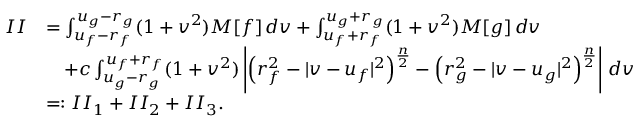<formula> <loc_0><loc_0><loc_500><loc_500>\begin{array} { r l } { I I } & { = \int _ { u _ { f } - r _ { f } } ^ { u _ { g } - r _ { g } } ( 1 + v ^ { 2 } ) M [ f ] \, d v + \int _ { u _ { f } + r _ { f } } ^ { u _ { g } + r _ { g } } ( 1 + v ^ { 2 } ) M [ g ] \, d v } \\ & { \quad + c \int _ { u _ { g } - r _ { g } } ^ { u _ { f } + r _ { f } } ( 1 + v ^ { 2 } ) \left | \left ( r _ { f } ^ { 2 } - | v - u _ { f } | ^ { 2 } \right ) ^ { \frac { n } { 2 } } - \left ( r _ { g } ^ { 2 } - | v - u _ { g } | ^ { 2 } \right ) ^ { \frac { n } { 2 } } \right | \, d v } \\ & { = \colon I I _ { 1 } + I I _ { 2 } + I I _ { 3 } . } \end{array}</formula> 